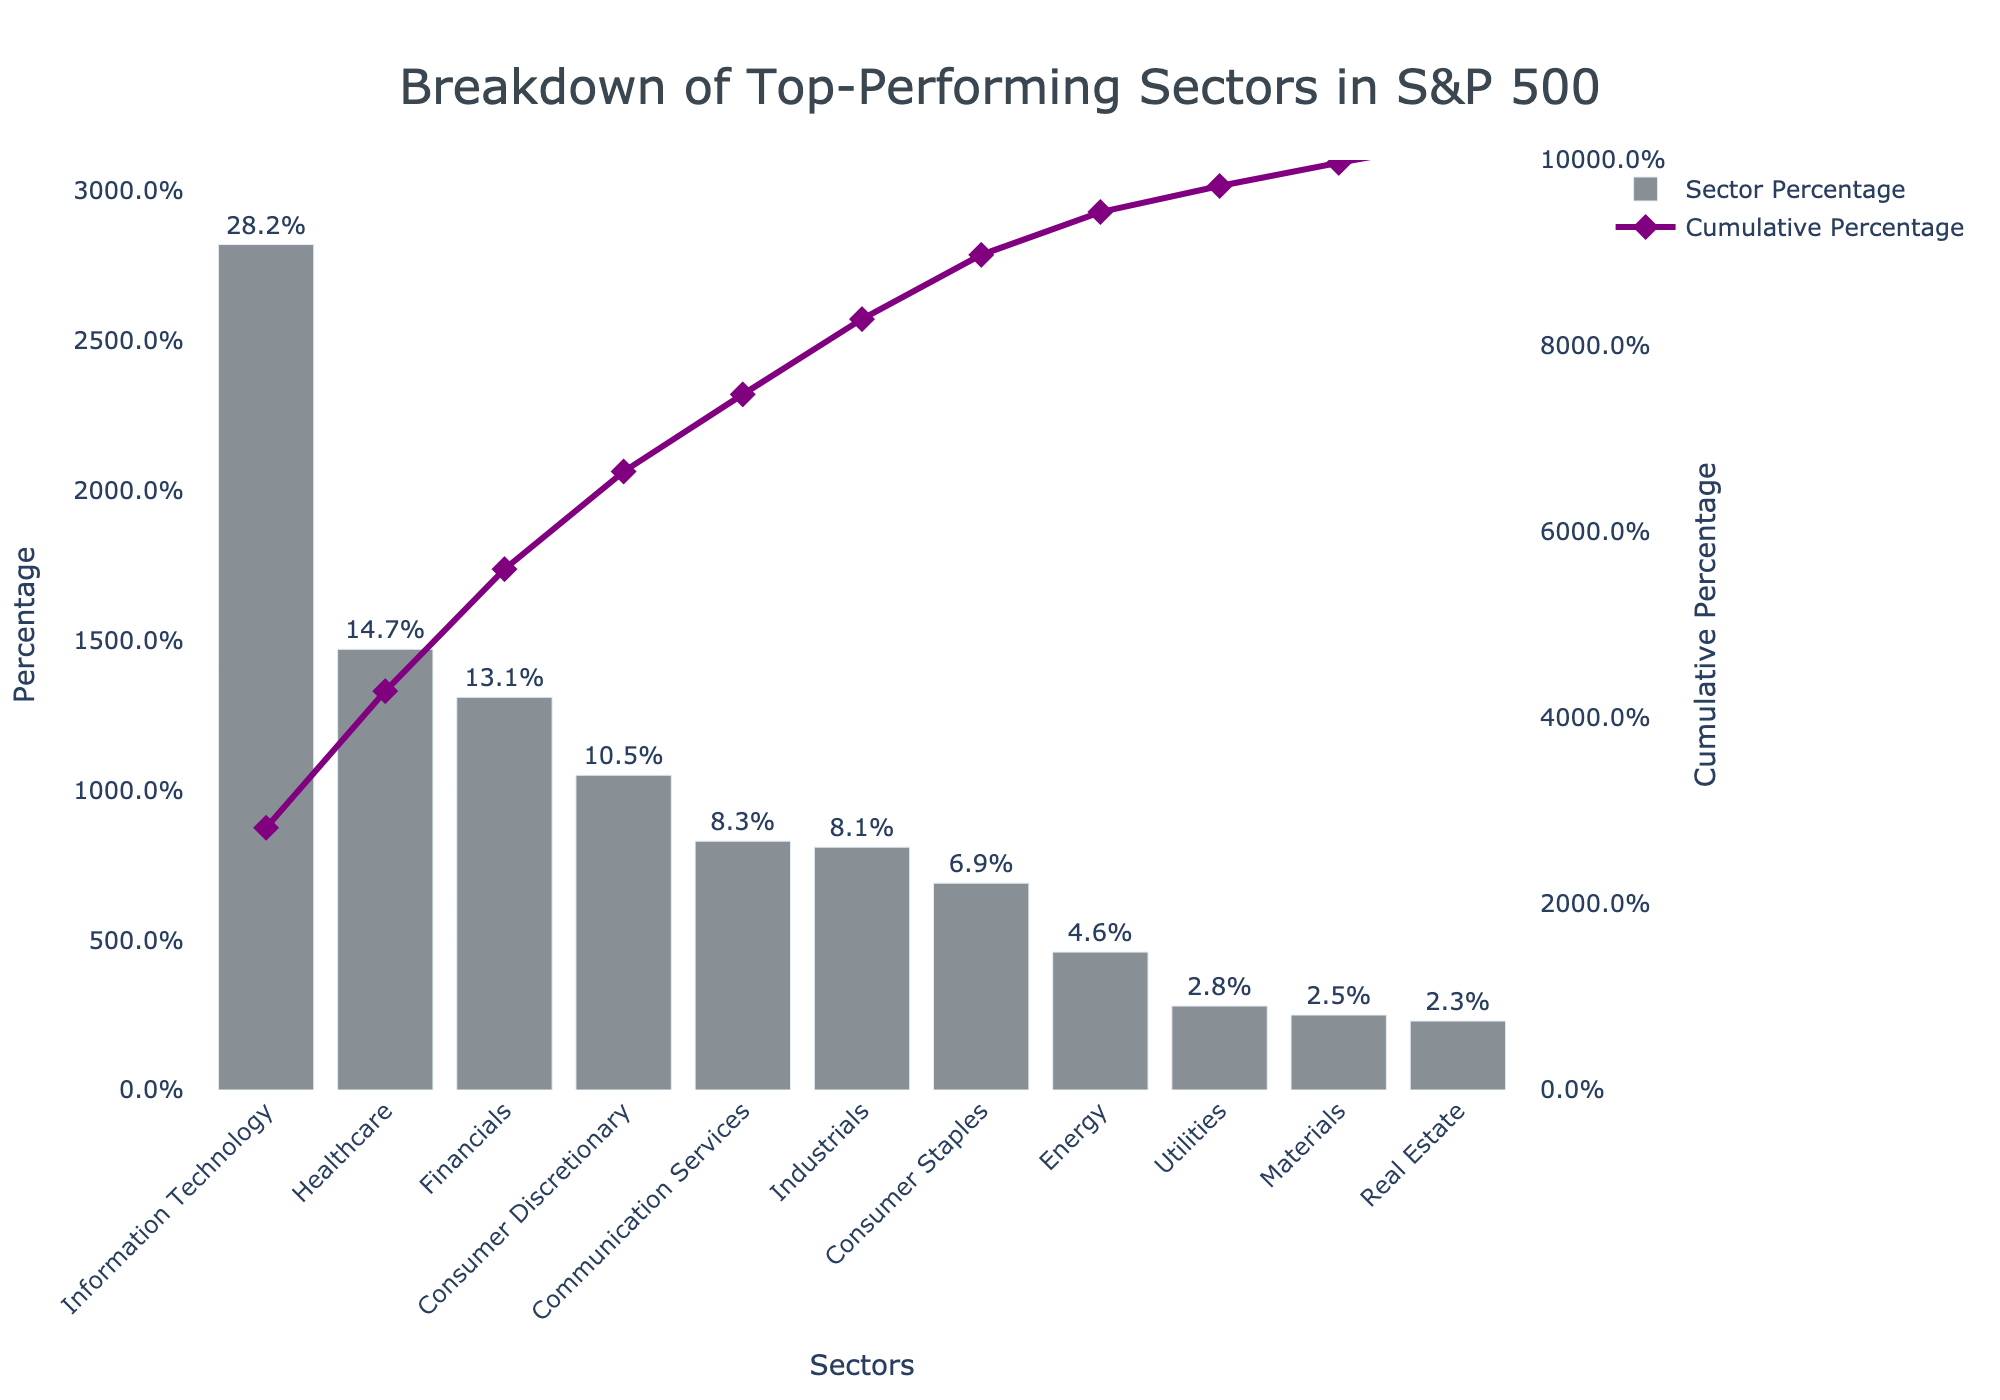What is the title of the Pareto chart? The title of a Pareto chart is typically placed at the top center of the chart and can be read directly from the figure.
Answer: Breakdown of Top-Performing Sectors in S&P 500 Which sector has the highest percentage? The sector with the highest percentage will have the tallest bar in the bar chart.
Answer: Information Technology What is the percentage of the Financials sector? Find the Financials sector on the x-axis and read the value displayed at the top of its bar.
Answer: 13.1% How many sectors have a percentage greater than or equal to 10%? Identify the bars whose height corresponds to values greater than or equal to 10% and count them.
Answer: 4 What is the cumulative percentage after adding the top three sectors? Add the percentages of the top three sectors and use the cumulative percentage line for verification.
Answer: 28.2% + 14.7% + 13.1% = 56.0% Which is the first sector where the cumulative line crosses 50%? Follow the cumulative percentage line and identify where it first exceeds 50% by checking corresponding sectors below.
Answer: Financials By how much does Information Technology exceed the Healthcare sector in percentage? Subtract the percentage of the Healthcare sector from the percentage of Information Technology.
Answer: 28.2% - 14.7% = 13.5% Which sector is the median in terms of percentage? The median sector will be the one in the middle position when all sectors are sorted by percentage in descending order. With 11 sectors, the 6th one is the median.
Answer: Industrials What is the combined percentage of the sectors with the lowest values? Sum up the percentages of the three sectors with the smallest values.
Answer: 2.5% + 2.3% + 2.8% = 7.6% What range does the y-axis representing "Percentage" span? Look at the y-axis labeled "Percentage" to find the minimum and maximum values displayed.
Answer: 0% to 31% 